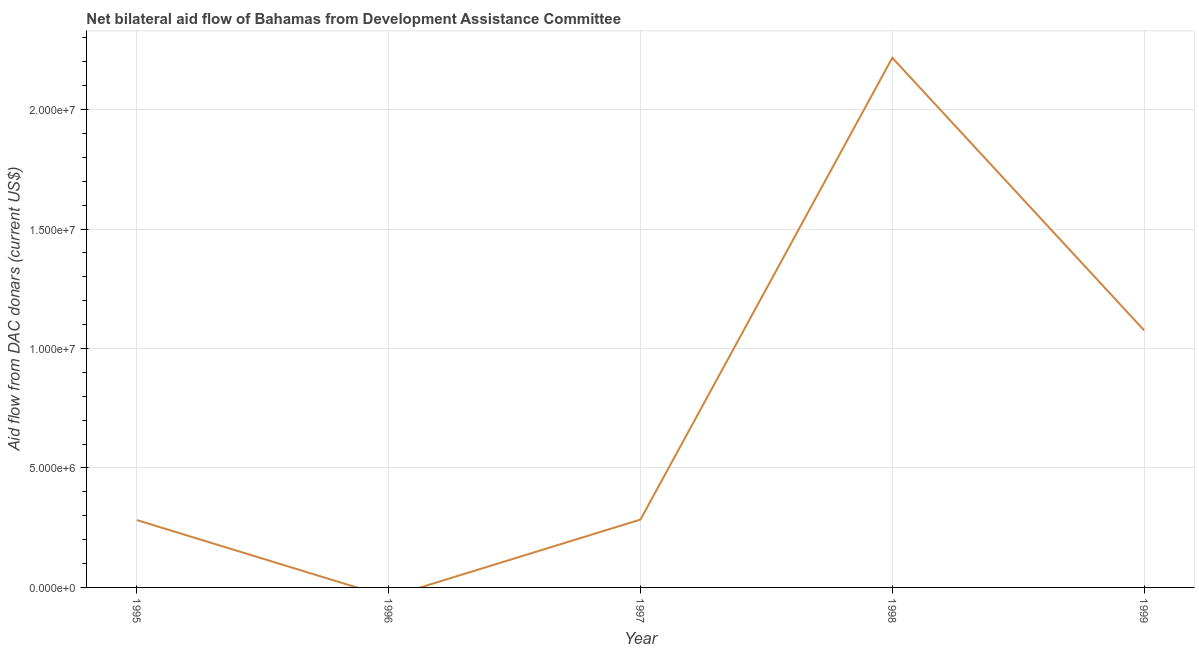What is the net bilateral aid flows from dac donors in 1999?
Give a very brief answer. 1.08e+07. Across all years, what is the maximum net bilateral aid flows from dac donors?
Your answer should be very brief. 2.22e+07. In which year was the net bilateral aid flows from dac donors maximum?
Provide a short and direct response. 1998. What is the sum of the net bilateral aid flows from dac donors?
Offer a terse response. 3.86e+07. What is the difference between the net bilateral aid flows from dac donors in 1997 and 1998?
Provide a succinct answer. -1.93e+07. What is the average net bilateral aid flows from dac donors per year?
Your answer should be very brief. 7.72e+06. What is the median net bilateral aid flows from dac donors?
Offer a terse response. 2.84e+06. What is the ratio of the net bilateral aid flows from dac donors in 1997 to that in 1998?
Make the answer very short. 0.13. Is the net bilateral aid flows from dac donors in 1995 less than that in 1997?
Your answer should be very brief. Yes. What is the difference between the highest and the second highest net bilateral aid flows from dac donors?
Give a very brief answer. 1.14e+07. Is the sum of the net bilateral aid flows from dac donors in 1995 and 1997 greater than the maximum net bilateral aid flows from dac donors across all years?
Offer a terse response. No. What is the difference between the highest and the lowest net bilateral aid flows from dac donors?
Make the answer very short. 2.22e+07. In how many years, is the net bilateral aid flows from dac donors greater than the average net bilateral aid flows from dac donors taken over all years?
Your answer should be very brief. 2. Are the values on the major ticks of Y-axis written in scientific E-notation?
Provide a short and direct response. Yes. Does the graph contain grids?
Your response must be concise. Yes. What is the title of the graph?
Your answer should be compact. Net bilateral aid flow of Bahamas from Development Assistance Committee. What is the label or title of the X-axis?
Provide a short and direct response. Year. What is the label or title of the Y-axis?
Your response must be concise. Aid flow from DAC donars (current US$). What is the Aid flow from DAC donars (current US$) of 1995?
Keep it short and to the point. 2.82e+06. What is the Aid flow from DAC donars (current US$) in 1997?
Ensure brevity in your answer.  2.84e+06. What is the Aid flow from DAC donars (current US$) of 1998?
Your response must be concise. 2.22e+07. What is the Aid flow from DAC donars (current US$) in 1999?
Give a very brief answer. 1.08e+07. What is the difference between the Aid flow from DAC donars (current US$) in 1995 and 1998?
Offer a terse response. -1.94e+07. What is the difference between the Aid flow from DAC donars (current US$) in 1995 and 1999?
Provide a short and direct response. -7.94e+06. What is the difference between the Aid flow from DAC donars (current US$) in 1997 and 1998?
Provide a succinct answer. -1.93e+07. What is the difference between the Aid flow from DAC donars (current US$) in 1997 and 1999?
Your answer should be very brief. -7.92e+06. What is the difference between the Aid flow from DAC donars (current US$) in 1998 and 1999?
Your answer should be very brief. 1.14e+07. What is the ratio of the Aid flow from DAC donars (current US$) in 1995 to that in 1998?
Ensure brevity in your answer.  0.13. What is the ratio of the Aid flow from DAC donars (current US$) in 1995 to that in 1999?
Offer a very short reply. 0.26. What is the ratio of the Aid flow from DAC donars (current US$) in 1997 to that in 1998?
Ensure brevity in your answer.  0.13. What is the ratio of the Aid flow from DAC donars (current US$) in 1997 to that in 1999?
Give a very brief answer. 0.26. What is the ratio of the Aid flow from DAC donars (current US$) in 1998 to that in 1999?
Keep it short and to the point. 2.06. 